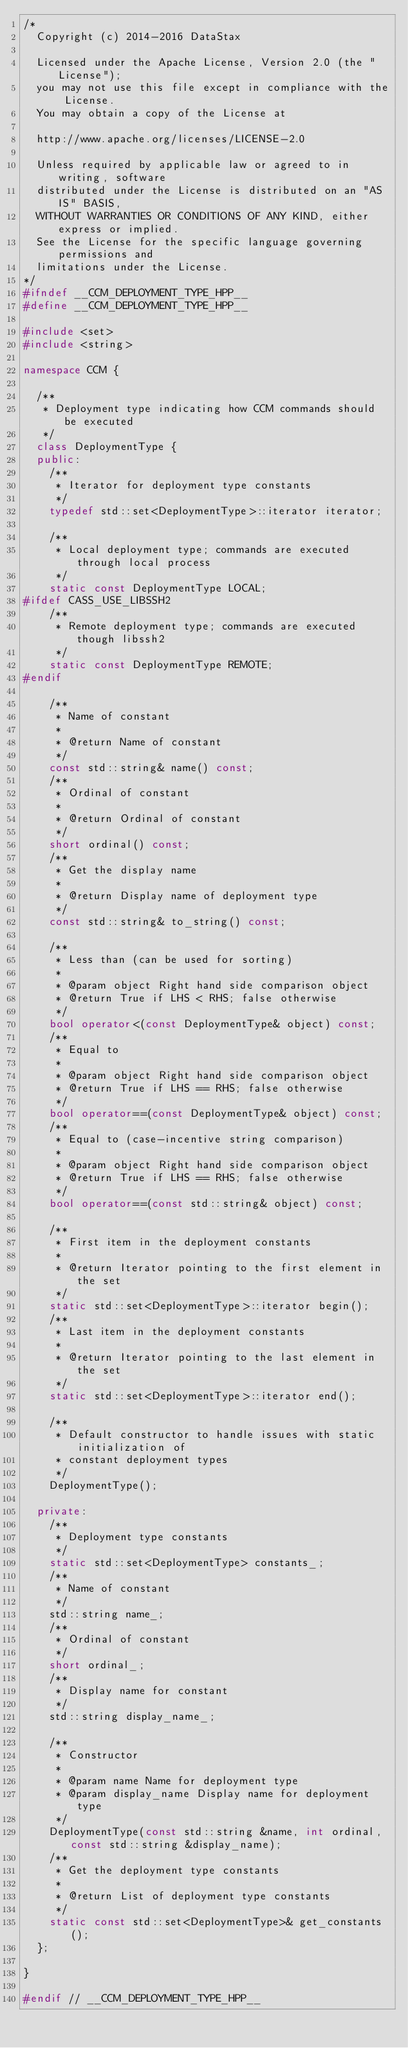<code> <loc_0><loc_0><loc_500><loc_500><_C++_>/*
  Copyright (c) 2014-2016 DataStax

  Licensed under the Apache License, Version 2.0 (the "License");
  you may not use this file except in compliance with the License.
  You may obtain a copy of the License at

  http://www.apache.org/licenses/LICENSE-2.0

  Unless required by applicable law or agreed to in writing, software
  distributed under the License is distributed on an "AS IS" BASIS,
  WITHOUT WARRANTIES OR CONDITIONS OF ANY KIND, either express or implied.
  See the License for the specific language governing permissions and
  limitations under the License.
*/
#ifndef __CCM_DEPLOYMENT_TYPE_HPP__
#define __CCM_DEPLOYMENT_TYPE_HPP__

#include <set>
#include <string>

namespace CCM {

  /**
   * Deployment type indicating how CCM commands should be executed
   */
  class DeploymentType {
  public:
    /**
     * Iterator for deployment type constants
     */
    typedef std::set<DeploymentType>::iterator iterator;

    /**
     * Local deployment type; commands are executed through local process
     */
    static const DeploymentType LOCAL;
#ifdef CASS_USE_LIBSSH2
    /**
     * Remote deployment type; commands are executed though libssh2
     */
    static const DeploymentType REMOTE;
#endif

    /**
     * Name of constant
     *
     * @return Name of constant
     */
    const std::string& name() const;
    /**
     * Ordinal of constant
     *
     * @return Ordinal of constant
     */
    short ordinal() const;
    /**
     * Get the display name
     *
     * @return Display name of deployment type
     */
    const std::string& to_string() const;

    /**
     * Less than (can be used for sorting)
     *
     * @param object Right hand side comparison object
     * @return True if LHS < RHS; false otherwise
     */
    bool operator<(const DeploymentType& object) const;
    /**
     * Equal to
     *
     * @param object Right hand side comparison object
     * @return True if LHS == RHS; false otherwise
     */
    bool operator==(const DeploymentType& object) const;
    /**
     * Equal to (case-incentive string comparison)
     *
     * @param object Right hand side comparison object
     * @return True if LHS == RHS; false otherwise
     */
    bool operator==(const std::string& object) const;

    /**
     * First item in the deployment constants
     *
     * @return Iterator pointing to the first element in the set
     */
    static std::set<DeploymentType>::iterator begin();
    /**
     * Last item in the deployment constants
     *
     * @return Iterator pointing to the last element in the set
     */
    static std::set<DeploymentType>::iterator end();

    /**
     * Default constructor to handle issues with static initialization of
     * constant deployment types
     */
    DeploymentType();

  private:
    /**
     * Deployment type constants
     */
    static std::set<DeploymentType> constants_;
    /**
     * Name of constant
     */
    std::string name_;
    /**
     * Ordinal of constant
     */
    short ordinal_;
    /**
     * Display name for constant
     */
    std::string display_name_;

    /**
     * Constructor
     *
     * @param name Name for deployment type
     * @param display_name Display name for deployment type
     */
    DeploymentType(const std::string &name, int ordinal, const std::string &display_name);
    /**
     * Get the deployment type constants
     *
     * @return List of deployment type constants
     */
    static const std::set<DeploymentType>& get_constants();
  };

}

#endif // __CCM_DEPLOYMENT_TYPE_HPP__
</code> 